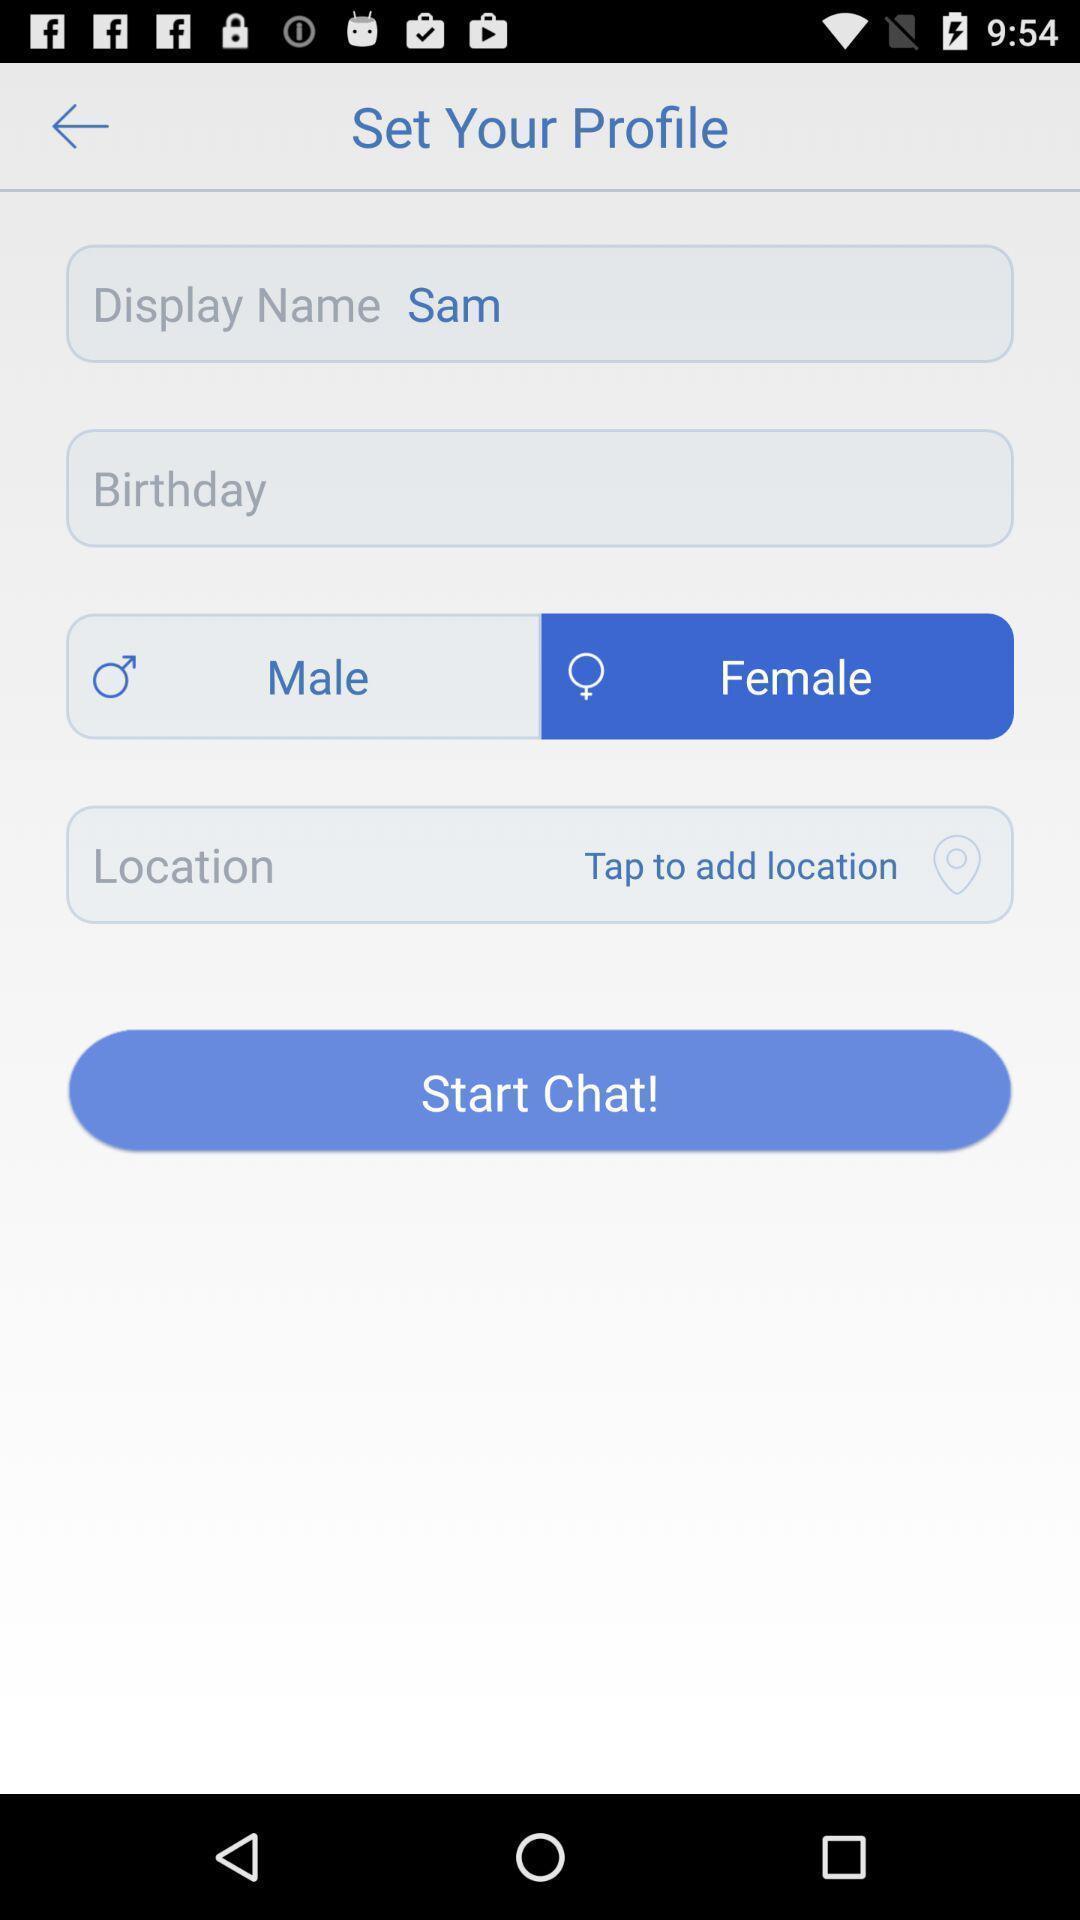Summarize the main components in this picture. Window displaying to set up profile. 